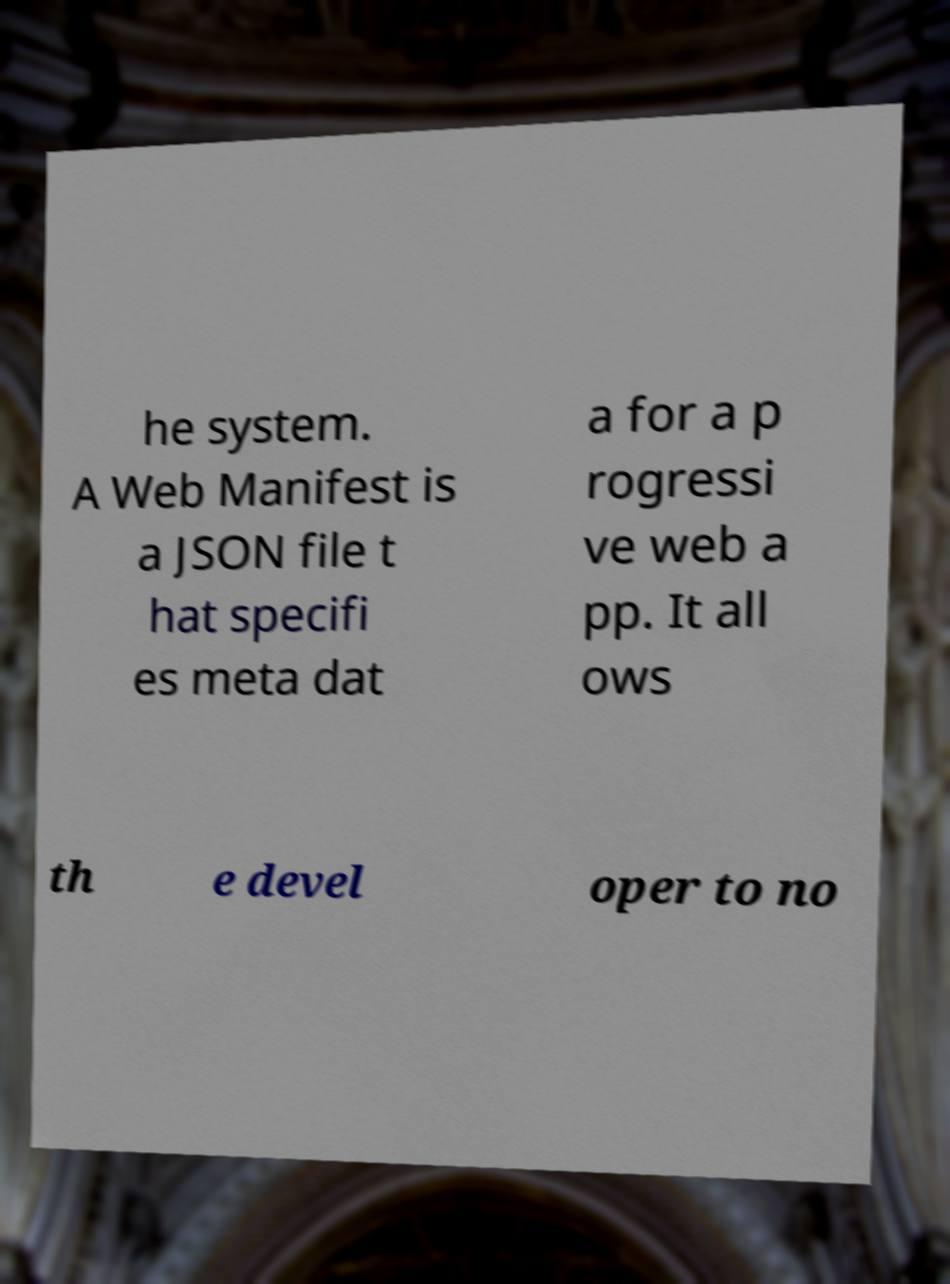For documentation purposes, I need the text within this image transcribed. Could you provide that? he system. A Web Manifest is a JSON file t hat specifi es meta dat a for a p rogressi ve web a pp. It all ows th e devel oper to no 